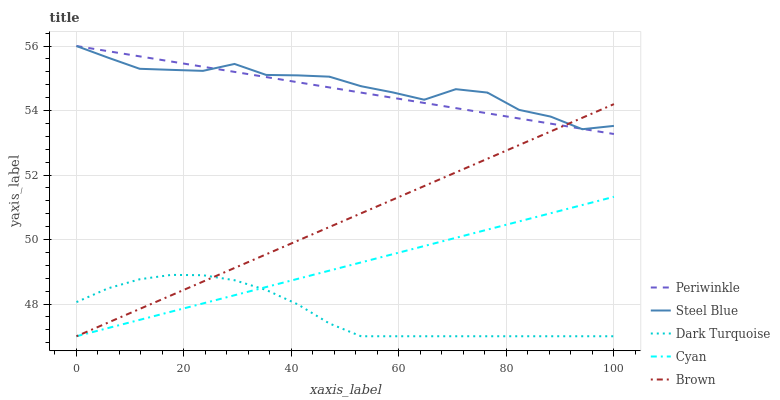Does Dark Turquoise have the minimum area under the curve?
Answer yes or no. Yes. Does Steel Blue have the maximum area under the curve?
Answer yes or no. Yes. Does Periwinkle have the minimum area under the curve?
Answer yes or no. No. Does Periwinkle have the maximum area under the curve?
Answer yes or no. No. Is Cyan the smoothest?
Answer yes or no. Yes. Is Steel Blue the roughest?
Answer yes or no. Yes. Is Periwinkle the smoothest?
Answer yes or no. No. Is Periwinkle the roughest?
Answer yes or no. No. Does Periwinkle have the lowest value?
Answer yes or no. No. Does Steel Blue have the highest value?
Answer yes or no. Yes. Does Brown have the highest value?
Answer yes or no. No. Is Cyan less than Steel Blue?
Answer yes or no. Yes. Is Steel Blue greater than Dark Turquoise?
Answer yes or no. Yes. Does Cyan intersect Dark Turquoise?
Answer yes or no. Yes. Is Cyan less than Dark Turquoise?
Answer yes or no. No. Is Cyan greater than Dark Turquoise?
Answer yes or no. No. Does Cyan intersect Steel Blue?
Answer yes or no. No. 